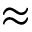<formula> <loc_0><loc_0><loc_500><loc_500>\approx</formula> 